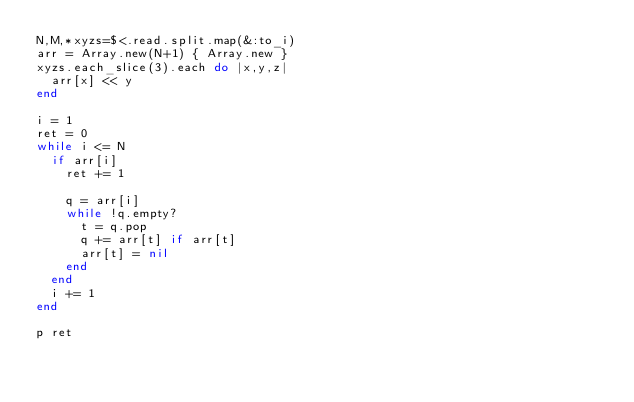Convert code to text. <code><loc_0><loc_0><loc_500><loc_500><_Ruby_>N,M,*xyzs=$<.read.split.map(&:to_i)
arr = Array.new(N+1) { Array.new }
xyzs.each_slice(3).each do |x,y,z|
  arr[x] << y
end

i = 1
ret = 0
while i <= N
  if arr[i]
    ret += 1

    q = arr[i]
    while !q.empty?
      t = q.pop
      q += arr[t] if arr[t]
      arr[t] = nil
    end
  end
  i += 1
end

p ret


</code> 